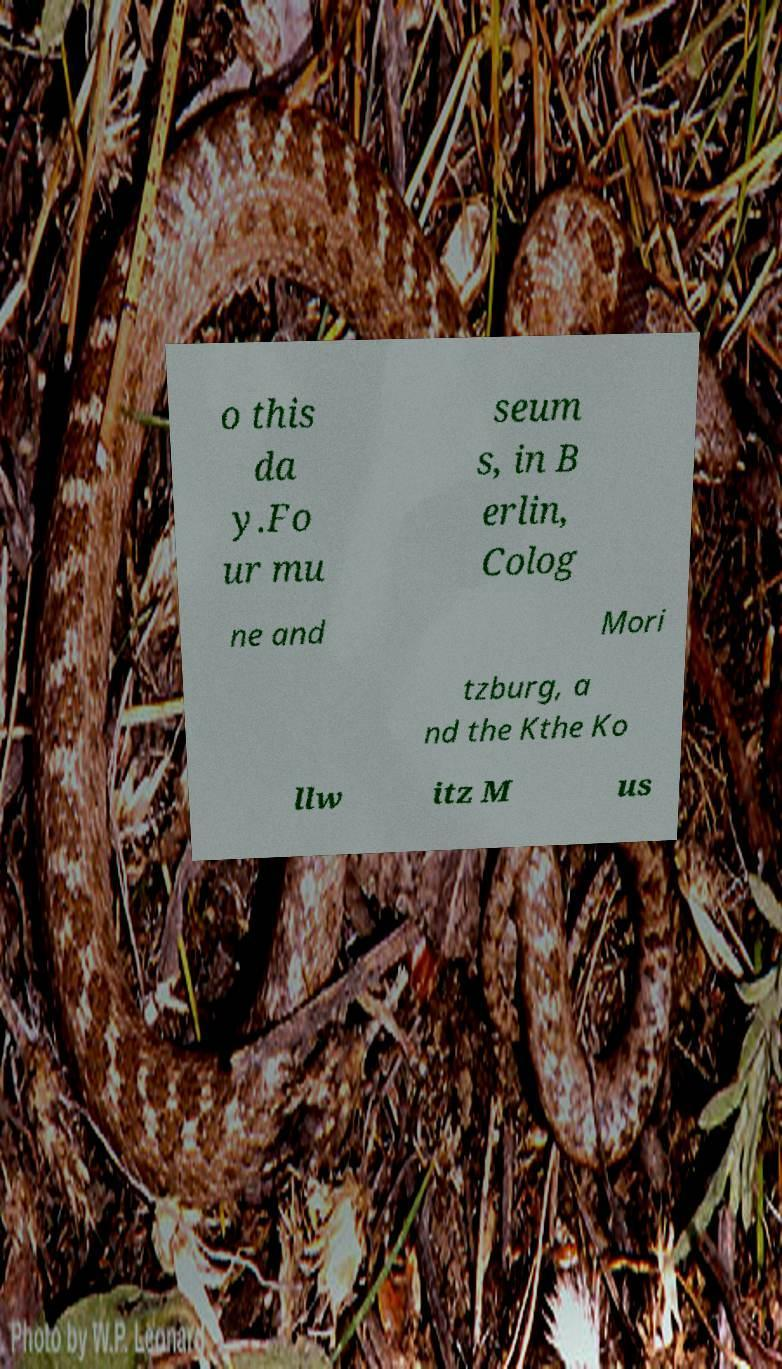Can you accurately transcribe the text from the provided image for me? o this da y.Fo ur mu seum s, in B erlin, Colog ne and Mori tzburg, a nd the Kthe Ko llw itz M us 